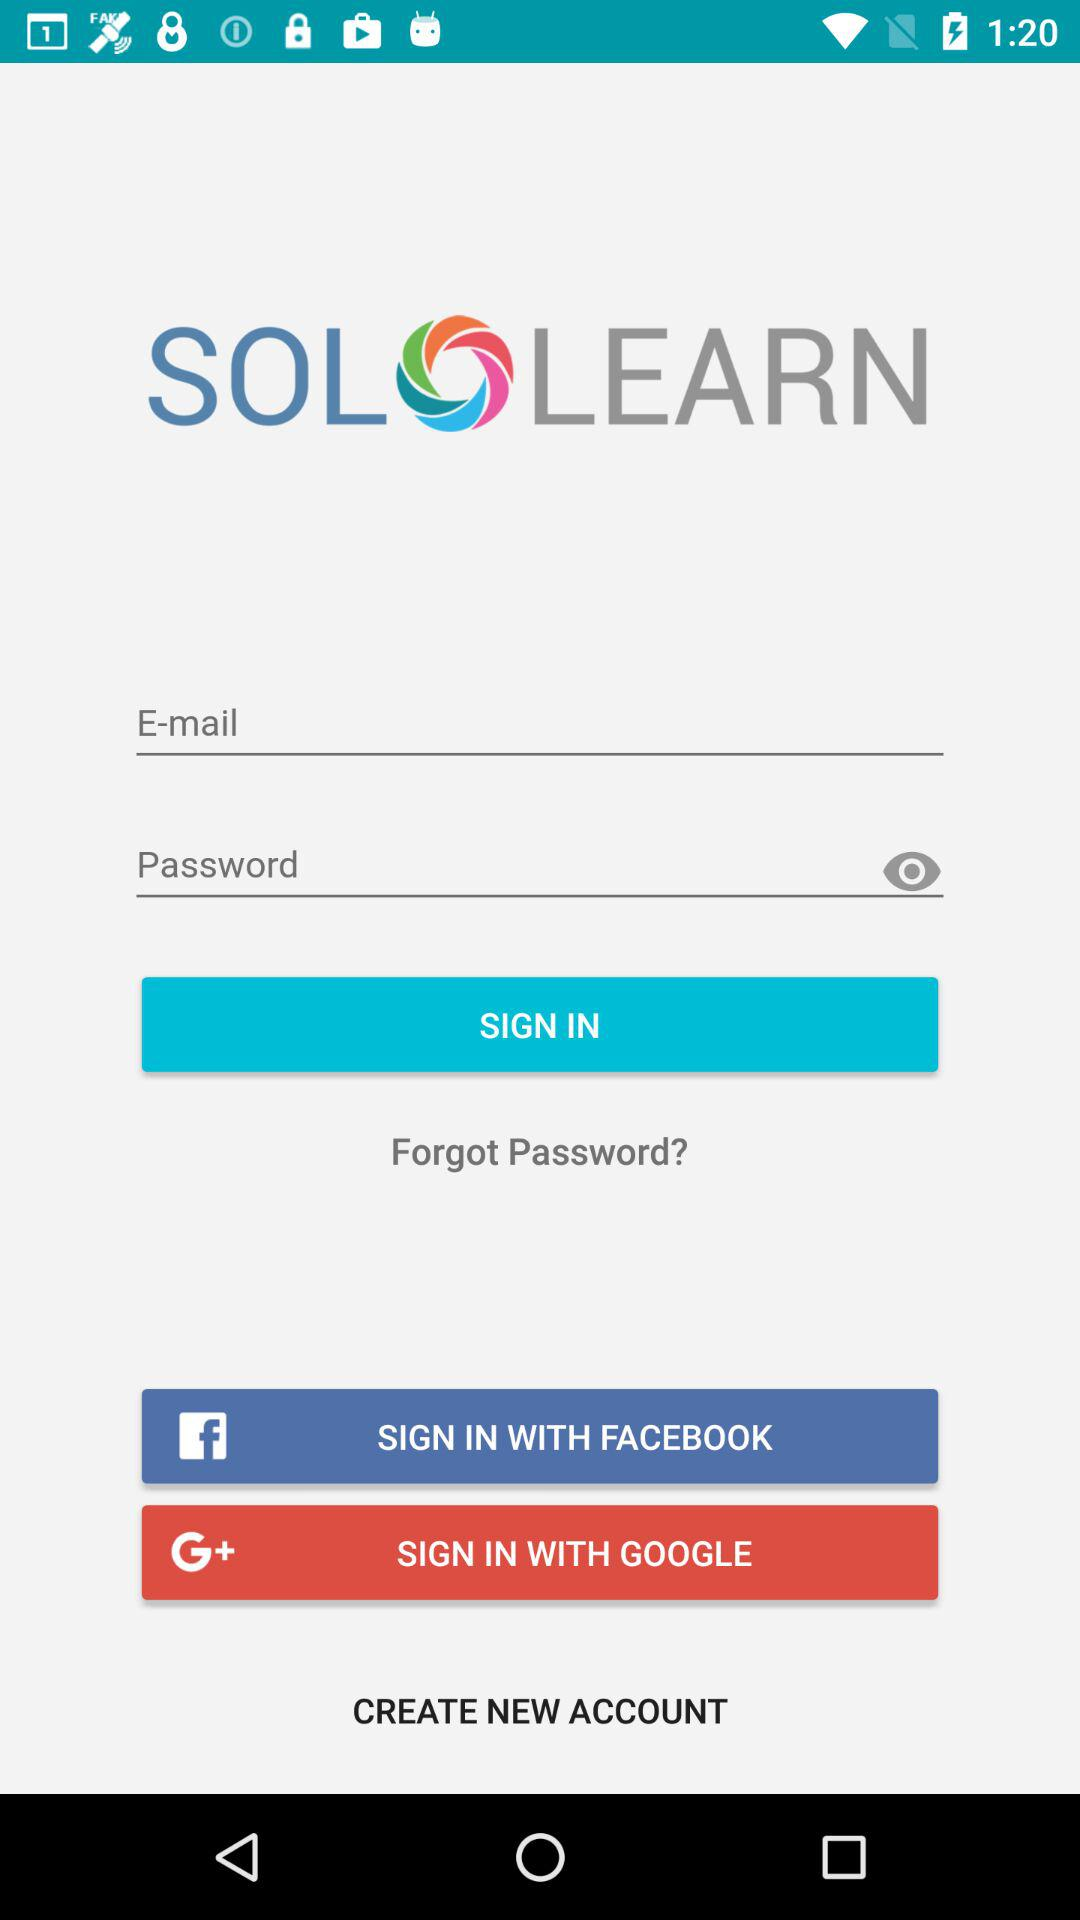What accounts can I use to sign in? You can use "E-mail", "FACEBOOK" and "GOOGLE" accounts to sign in. 